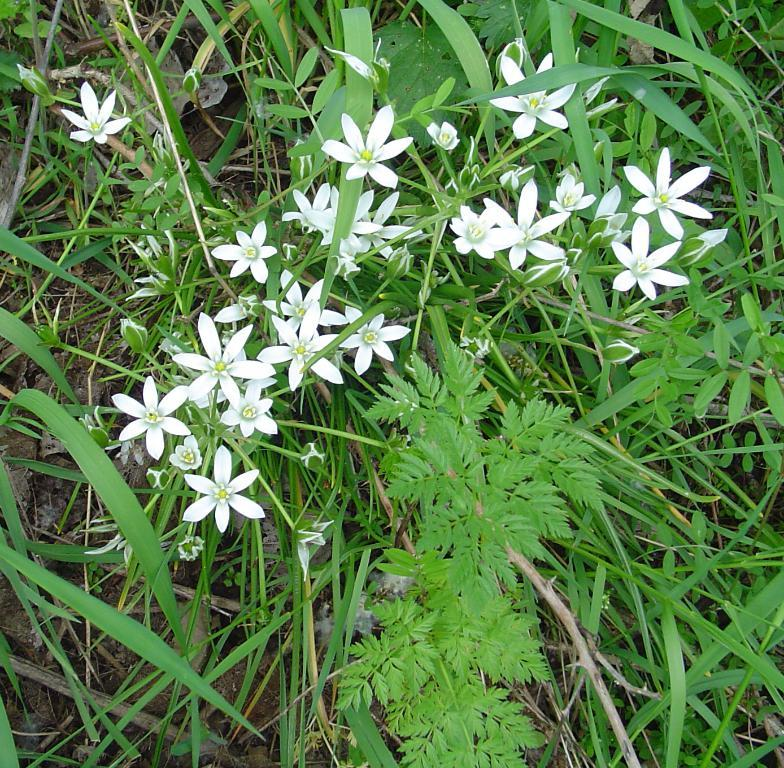What is the main subject in the center of the image? There are flowers in the center of the image. What type of vegetation can be seen on the ground in the image? There is grass on the ground in the image. What letter can be seen on the pancake in the image? There is no pancake present in the image, so it is not possible to determine if there is a letter on it. 